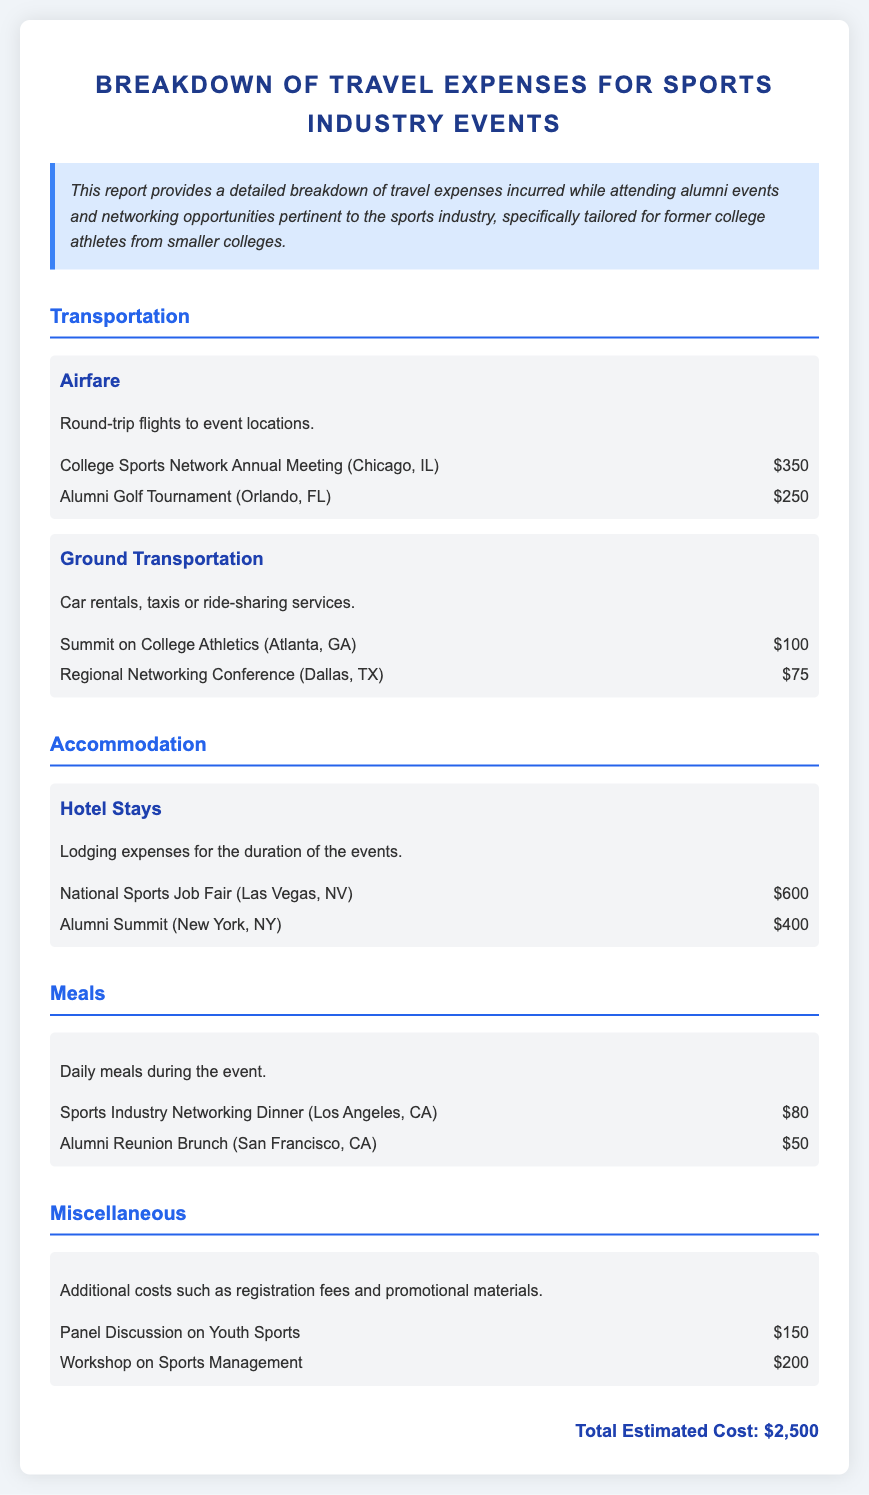What is the total estimated cost? The total estimated cost is provided at the end of the document as the sum of all expenses listed.
Answer: $2,500 How much was spent on airfare for the Alumni Golf Tournament? Airfare expenses are listed under transportation, with specific amounts for each event noted.
Answer: $250 What was the accommodation expense for the National Sports Job Fair? Accommodation details are provided under a specific section, indicating costs associated with hotel stays per event.
Answer: $600 What is the cost of meals for the Sports Industry Networking Dinner? Meal expenses are noted with specific amounts for various events as part of the meals section in the document.
Answer: $80 Which event incurred the highest ground transportation cost? Ground transportation costs are listed, and identifying the highest requires comparing the amounts associated with each event.
Answer: $100 What were the miscellaneous expenses for the Workshop on Sports Management? Miscellaneous expenses are broken down by event, clearly indicating the costs for registration fees and other expenses.
Answer: $200 How many events are listed under accommodation expenses? Counting the number of distinct events under accommodation will yield the answer.
Answer: 2 What is provided in the summary of the report? The summary section offers an overview of the report, including its focus on travel expenses for a specific audience.
Answer: Detailed breakdown of travel expenses 